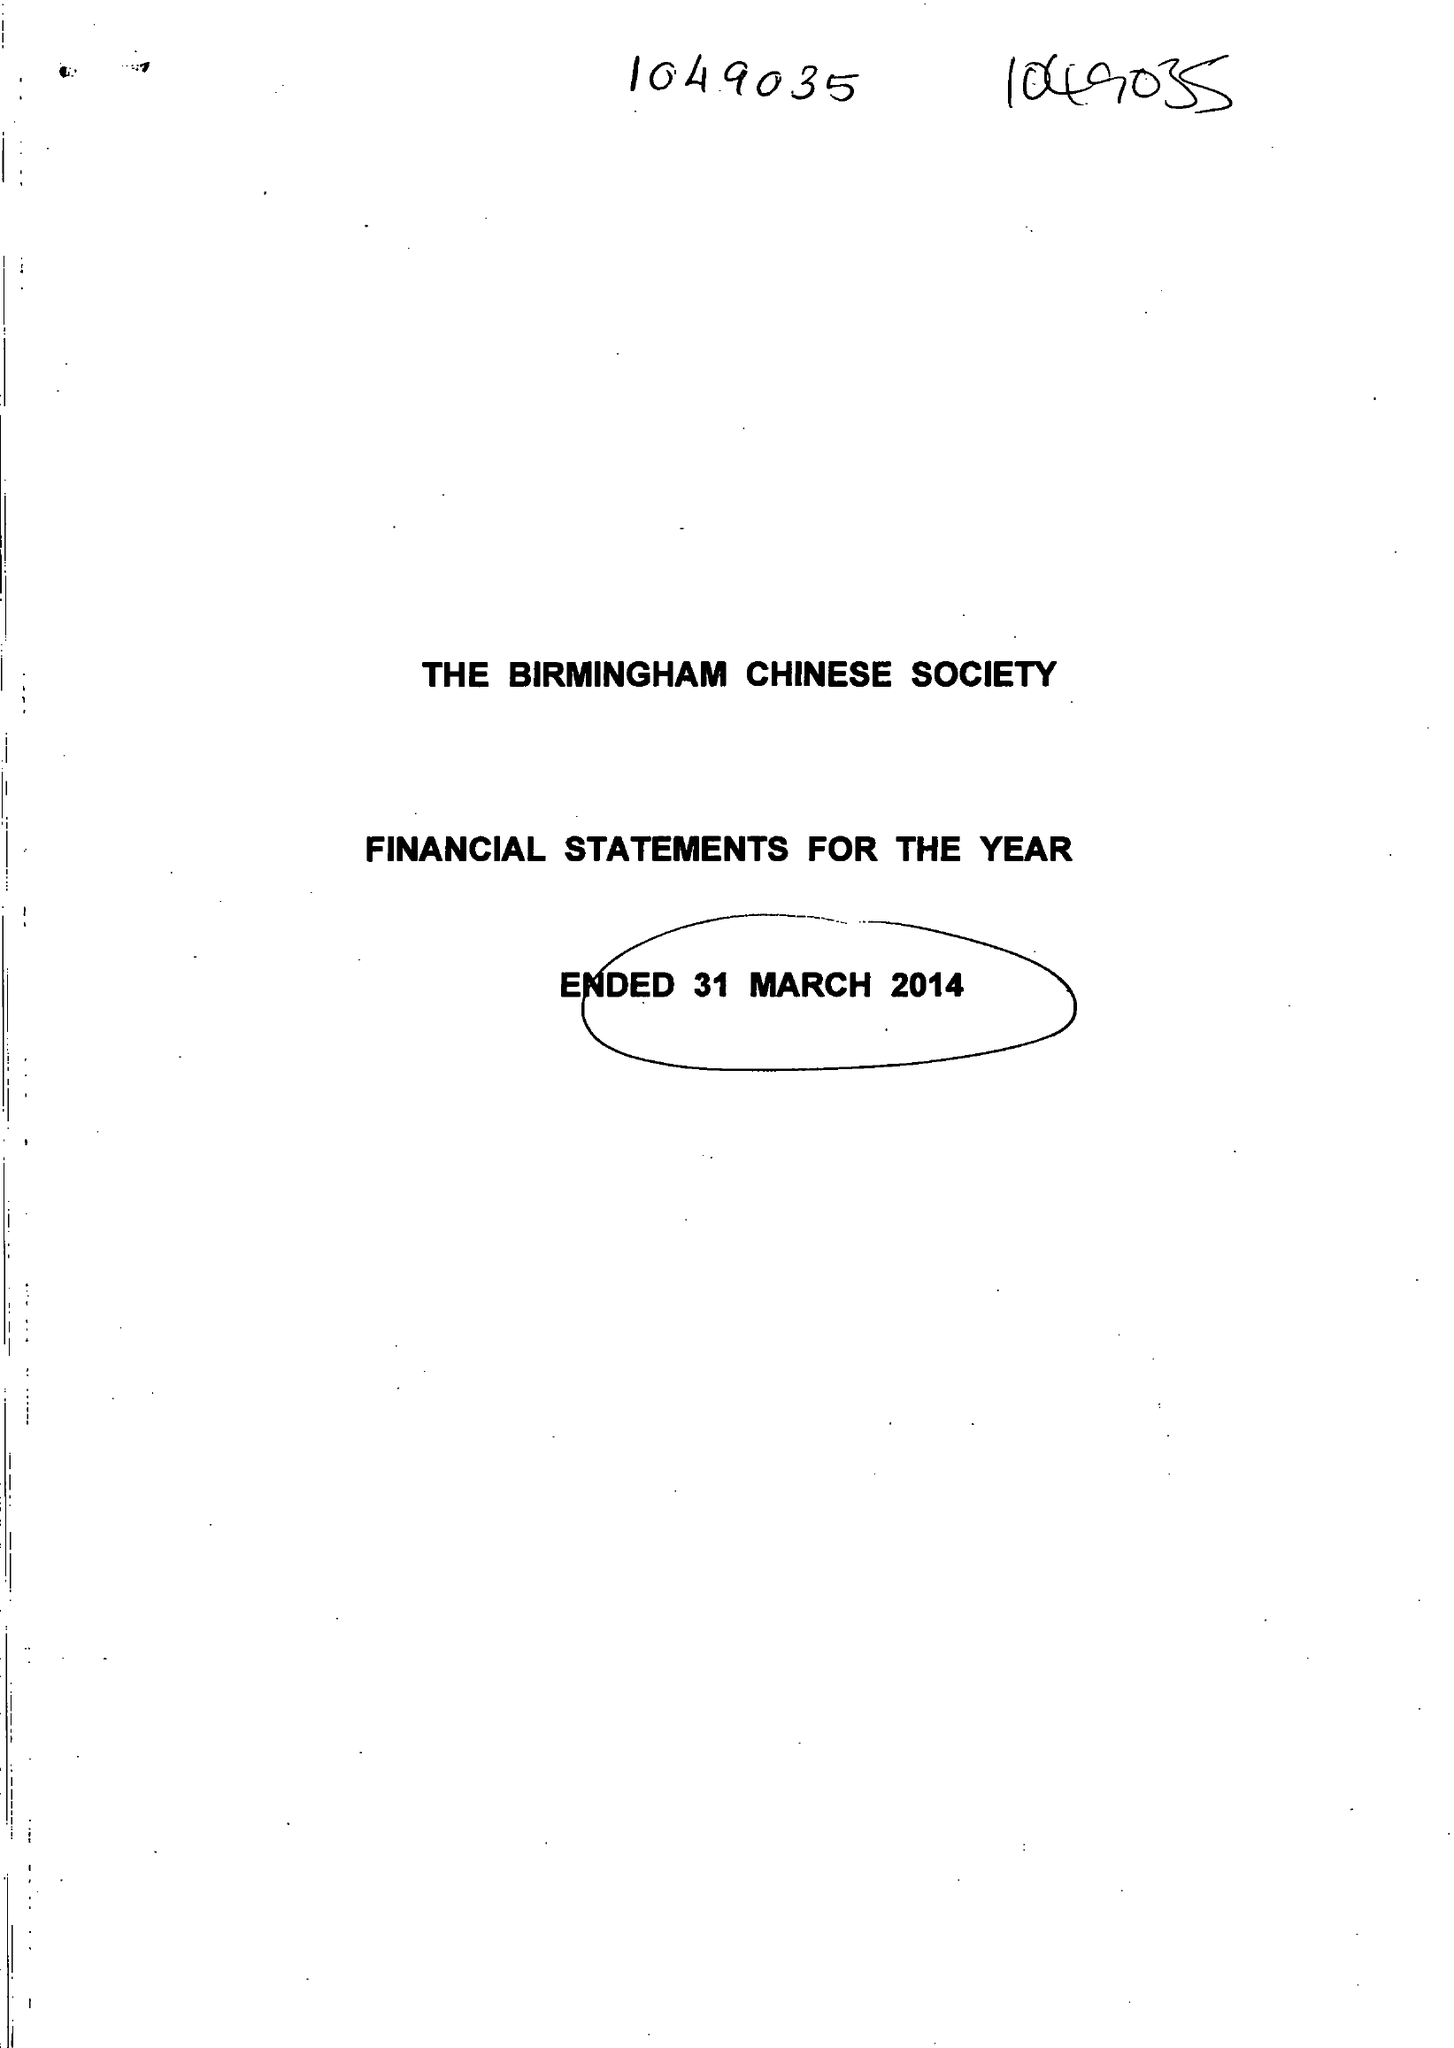What is the value for the spending_annually_in_british_pounds?
Answer the question using a single word or phrase. 34220.00 